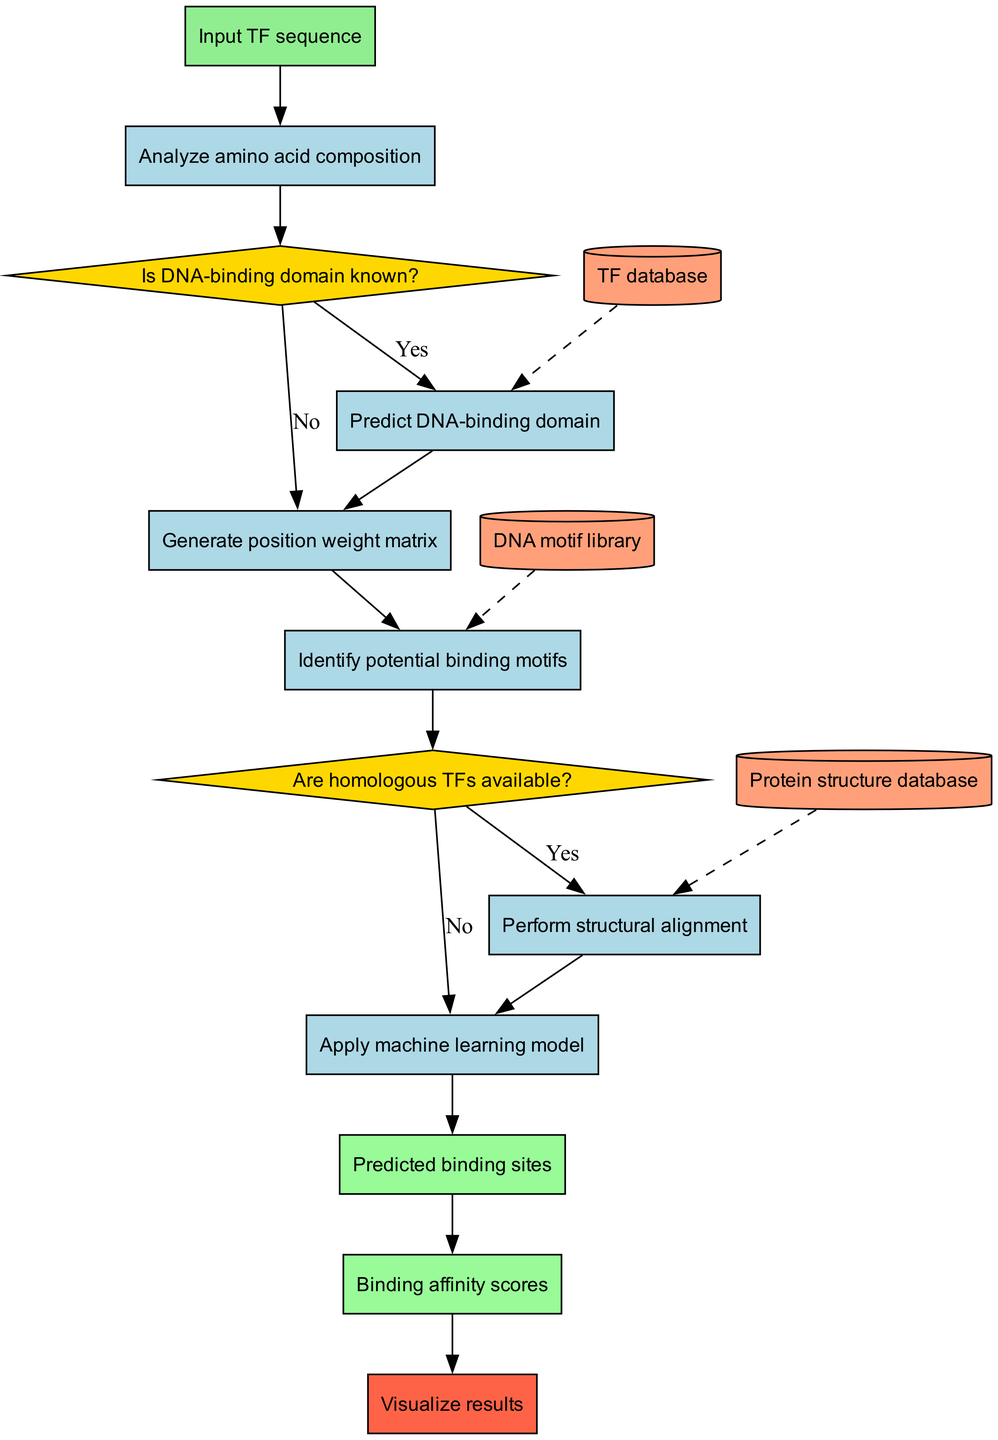What is the starting point of the flowchart? The flowchart begins with the node labeled "Input TF sequence." This is the initial step in the process that triggers the subsequent actions outlined in the diagram.
Answer: Input TF sequence How many processes are there in the flowchart? There are six processes in the flowchart that are shown as rectangular nodes. These processes guide the analysis of protein-DNA binding specificity.
Answer: 6 What decision follows the analysis of amino acid composition? After the analysis of amino acid composition, the next decision node is "Is DNA-binding domain known?" This node evaluates whether the DNA-binding domain has been identified.
Answer: Is DNA-binding domain known? How does the process proceed if the DNA-binding domain is unknown? If the DNA-binding domain is unknown (the answer is "No"), the flowchart directs the process to "Generate position weight matrix." This indicates a shift in the analysis pathway based on the knowledge of the domain.
Answer: Generate position weight matrix What is the relationship between the process "Perform structural alignment" and the decision "Are homologous TFs available?" The process "Perform structural alignment" directly follows the decision "Are homologous TFs available?" if the answer is "Yes." This indicates that if homologous transcription factors are present, the next step is to perform a structural alignment of the TFs.
Answer: Directly follows Which outputs are generated after applying the machine learning model? The flowchart shows two outputs generated after the machine learning model is applied: "Predicted binding sites" and "Binding affinity scores." These outputs represent the results of the predictive analysis.
Answer: Predicted binding sites, Binding affinity scores What type of data nodes are connected to the process "Predict DNA-binding domain"? The data node connected to the process "Predict DNA-binding domain" is "TF database." This shows the source of information required for predicting the DNA-binding domain of the transcription factor.
Answer: TF database If the answer to "Are homologous TFs available?" is "No," what process follows? If the answer is "No," the flowchart directs to "Apply machine learning model." This indicates that the pathway proceeds with machine learning despite not having homologous transcription factors available.
Answer: Apply machine learning model 